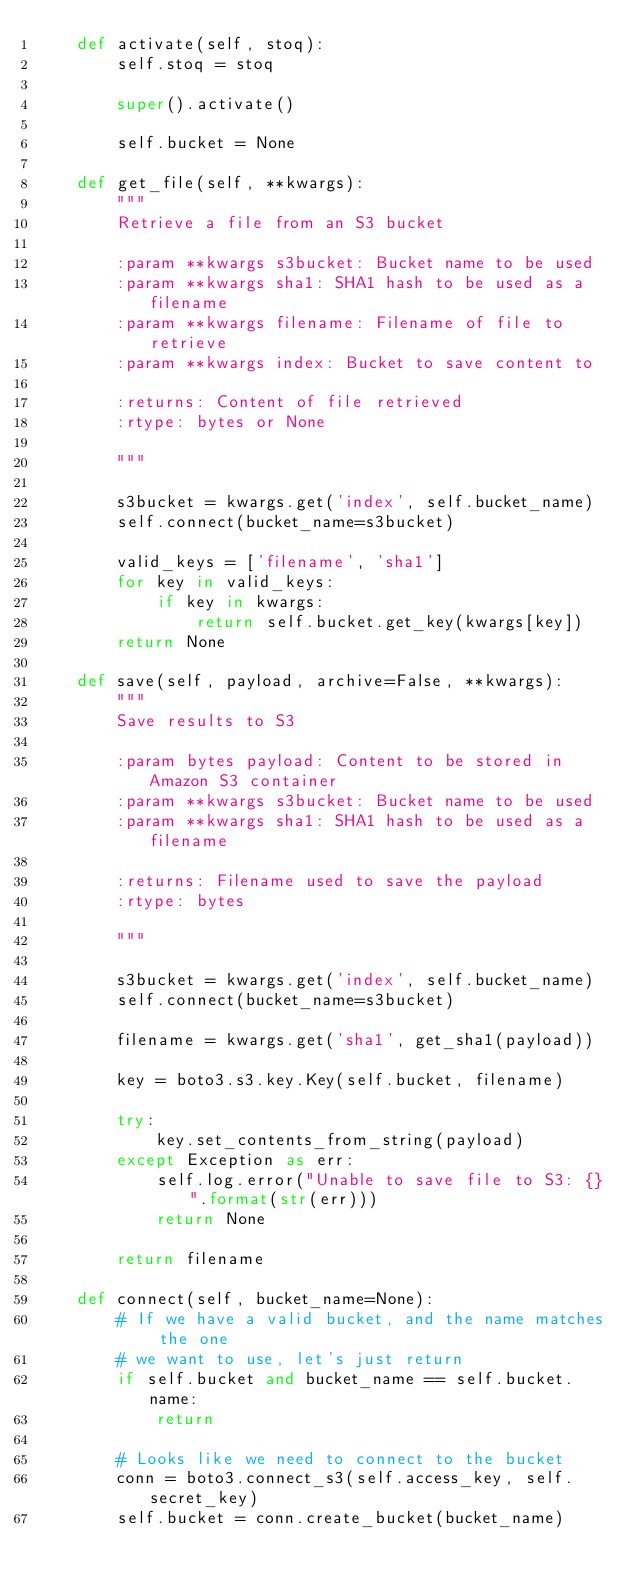Convert code to text. <code><loc_0><loc_0><loc_500><loc_500><_Python_>    def activate(self, stoq):
        self.stoq = stoq

        super().activate()

        self.bucket = None

    def get_file(self, **kwargs):
        """
        Retrieve a file from an S3 bucket

        :param **kwargs s3bucket: Bucket name to be used
        :param **kwargs sha1: SHA1 hash to be used as a filename
        :param **kwargs filename: Filename of file to retrieve
        :param **kwargs index: Bucket to save content to

        :returns: Content of file retrieved
        :rtype: bytes or None

        """

        s3bucket = kwargs.get('index', self.bucket_name)
        self.connect(bucket_name=s3bucket)

        valid_keys = ['filename', 'sha1']
        for key in valid_keys:
            if key in kwargs:
                return self.bucket.get_key(kwargs[key])
        return None

    def save(self, payload, archive=False, **kwargs):
        """
        Save results to S3

        :param bytes payload: Content to be stored in Amazon S3 container
        :param **kwargs s3bucket: Bucket name to be used
        :param **kwargs sha1: SHA1 hash to be used as a filename

        :returns: Filename used to save the payload
        :rtype: bytes

        """

        s3bucket = kwargs.get('index', self.bucket_name)
        self.connect(bucket_name=s3bucket)

        filename = kwargs.get('sha1', get_sha1(payload))

        key = boto3.s3.key.Key(self.bucket, filename)

        try:
            key.set_contents_from_string(payload)
        except Exception as err:
            self.log.error("Unable to save file to S3: {}".format(str(err)))
            return None

        return filename

    def connect(self, bucket_name=None):
        # If we have a valid bucket, and the name matches the one
        # we want to use, let's just return
        if self.bucket and bucket_name == self.bucket.name:
            return

        # Looks like we need to connect to the bucket
        conn = boto3.connect_s3(self.access_key, self.secret_key)
        self.bucket = conn.create_bucket(bucket_name)
</code> 